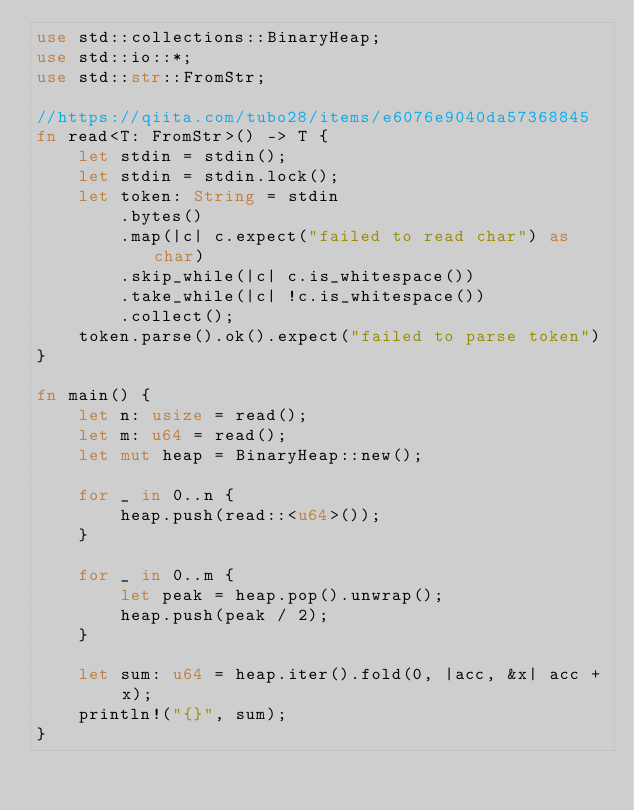<code> <loc_0><loc_0><loc_500><loc_500><_Rust_>use std::collections::BinaryHeap;
use std::io::*;
use std::str::FromStr;

//https://qiita.com/tubo28/items/e6076e9040da57368845
fn read<T: FromStr>() -> T {
    let stdin = stdin();
    let stdin = stdin.lock();
    let token: String = stdin
        .bytes()
        .map(|c| c.expect("failed to read char") as char)
        .skip_while(|c| c.is_whitespace())
        .take_while(|c| !c.is_whitespace())
        .collect();
    token.parse().ok().expect("failed to parse token")
}

fn main() {
    let n: usize = read();
    let m: u64 = read();
    let mut heap = BinaryHeap::new();

    for _ in 0..n {
        heap.push(read::<u64>());
    }

    for _ in 0..m {
        let peak = heap.pop().unwrap();
        heap.push(peak / 2);
    }

    let sum: u64 = heap.iter().fold(0, |acc, &x| acc + x);
    println!("{}", sum);
}
</code> 